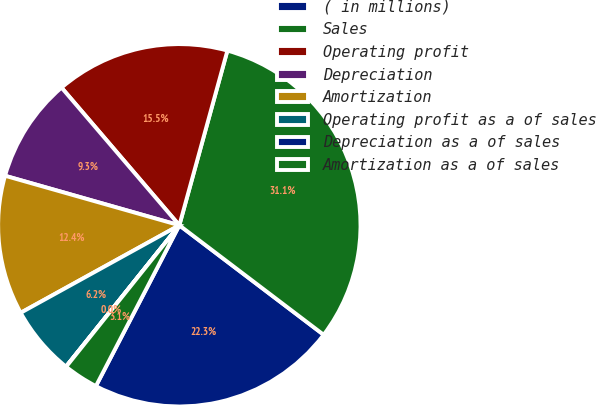Convert chart to OTSL. <chart><loc_0><loc_0><loc_500><loc_500><pie_chart><fcel>( in millions)<fcel>Sales<fcel>Operating profit<fcel>Depreciation<fcel>Amortization<fcel>Operating profit as a of sales<fcel>Depreciation as a of sales<fcel>Amortization as a of sales<nl><fcel>22.29%<fcel>31.06%<fcel>15.54%<fcel>9.33%<fcel>12.43%<fcel>6.22%<fcel>0.02%<fcel>3.12%<nl></chart> 